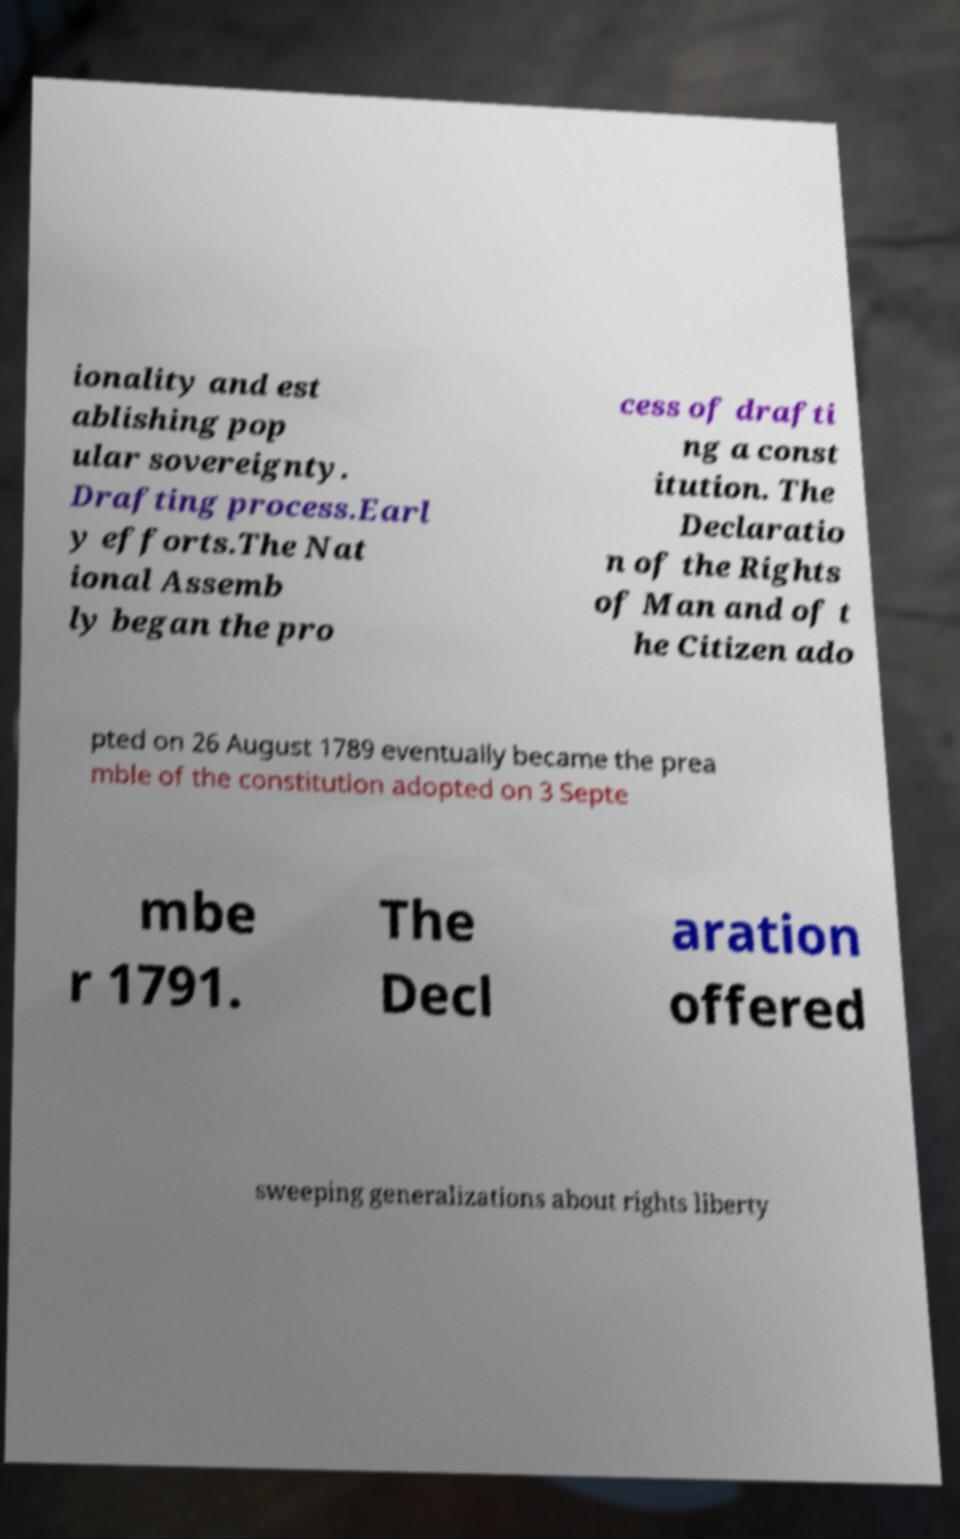Can you accurately transcribe the text from the provided image for me? ionality and est ablishing pop ular sovereignty. Drafting process.Earl y efforts.The Nat ional Assemb ly began the pro cess of drafti ng a const itution. The Declaratio n of the Rights of Man and of t he Citizen ado pted on 26 August 1789 eventually became the prea mble of the constitution adopted on 3 Septe mbe r 1791. The Decl aration offered sweeping generalizations about rights liberty 